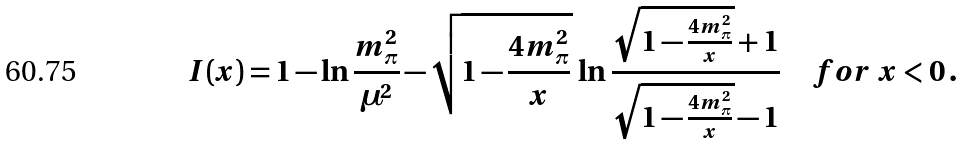<formula> <loc_0><loc_0><loc_500><loc_500>I ( x ) = 1 - \ln { \frac { m _ { \pi } ^ { 2 } } { \mu ^ { 2 } } } - \sqrt { 1 - { \frac { 4 m _ { \pi } ^ { 2 } } { x } } } \, \ln { \frac { \sqrt { 1 - { \frac { 4 m _ { \pi } ^ { 2 } } { x } } } + 1 } { \sqrt { 1 - { \frac { 4 m _ { \pi } ^ { 2 } } { x } } } - 1 } } \quad f o r \ x < 0 \, .</formula> 